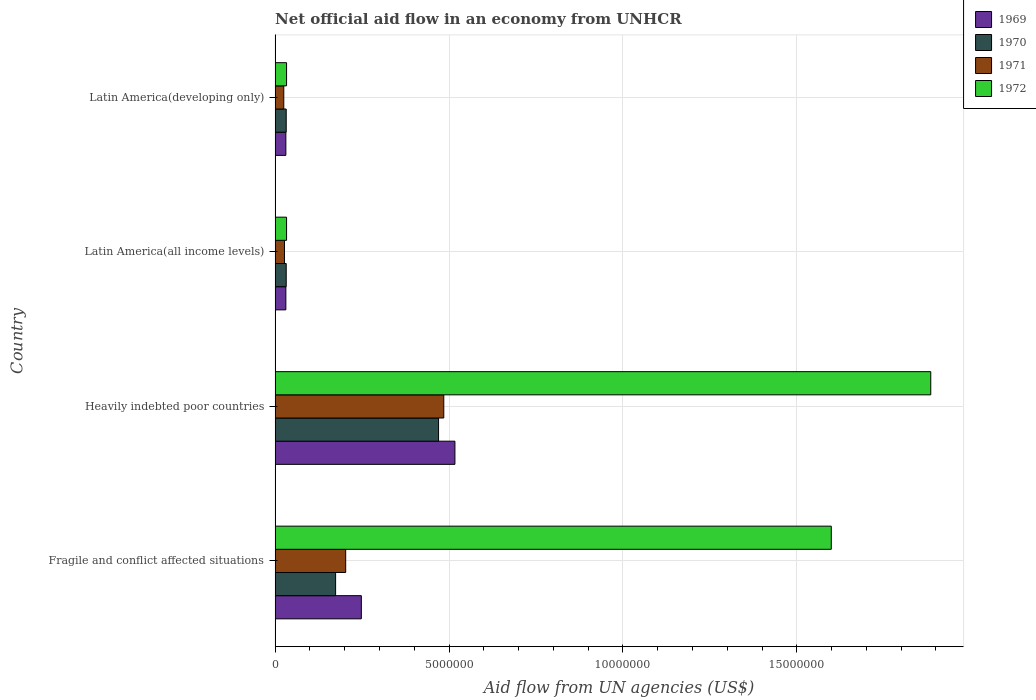How many groups of bars are there?
Offer a very short reply. 4. What is the label of the 4th group of bars from the top?
Offer a terse response. Fragile and conflict affected situations. In how many cases, is the number of bars for a given country not equal to the number of legend labels?
Offer a very short reply. 0. What is the net official aid flow in 1970 in Fragile and conflict affected situations?
Keep it short and to the point. 1.74e+06. Across all countries, what is the maximum net official aid flow in 1971?
Make the answer very short. 4.85e+06. In which country was the net official aid flow in 1970 maximum?
Offer a very short reply. Heavily indebted poor countries. In which country was the net official aid flow in 1972 minimum?
Your answer should be compact. Latin America(all income levels). What is the total net official aid flow in 1969 in the graph?
Keep it short and to the point. 8.27e+06. What is the difference between the net official aid flow in 1971 in Heavily indebted poor countries and that in Latin America(developing only)?
Ensure brevity in your answer.  4.60e+06. What is the difference between the net official aid flow in 1970 in Latin America(all income levels) and the net official aid flow in 1972 in Fragile and conflict affected situations?
Your answer should be compact. -1.57e+07. What is the average net official aid flow in 1972 per country?
Your response must be concise. 8.88e+06. In how many countries, is the net official aid flow in 1972 greater than 12000000 US$?
Offer a very short reply. 2. What is the ratio of the net official aid flow in 1972 in Heavily indebted poor countries to that in Latin America(all income levels)?
Offer a very short reply. 57.12. Is the net official aid flow in 1969 in Heavily indebted poor countries less than that in Latin America(all income levels)?
Your answer should be compact. No. Is the difference between the net official aid flow in 1971 in Heavily indebted poor countries and Latin America(developing only) greater than the difference between the net official aid flow in 1972 in Heavily indebted poor countries and Latin America(developing only)?
Make the answer very short. No. What is the difference between the highest and the second highest net official aid flow in 1969?
Keep it short and to the point. 2.69e+06. What is the difference between the highest and the lowest net official aid flow in 1972?
Offer a very short reply. 1.85e+07. In how many countries, is the net official aid flow in 1969 greater than the average net official aid flow in 1969 taken over all countries?
Offer a terse response. 2. Is the sum of the net official aid flow in 1971 in Fragile and conflict affected situations and Latin America(developing only) greater than the maximum net official aid flow in 1972 across all countries?
Offer a very short reply. No. What does the 4th bar from the top in Latin America(all income levels) represents?
Provide a succinct answer. 1969. What does the 1st bar from the bottom in Fragile and conflict affected situations represents?
Give a very brief answer. 1969. Is it the case that in every country, the sum of the net official aid flow in 1971 and net official aid flow in 1969 is greater than the net official aid flow in 1972?
Provide a short and direct response. No. How many bars are there?
Make the answer very short. 16. Are all the bars in the graph horizontal?
Offer a terse response. Yes. How many countries are there in the graph?
Provide a short and direct response. 4. Does the graph contain grids?
Your answer should be very brief. Yes. How many legend labels are there?
Your response must be concise. 4. How are the legend labels stacked?
Give a very brief answer. Vertical. What is the title of the graph?
Offer a very short reply. Net official aid flow in an economy from UNHCR. Does "1991" appear as one of the legend labels in the graph?
Ensure brevity in your answer.  No. What is the label or title of the X-axis?
Ensure brevity in your answer.  Aid flow from UN agencies (US$). What is the Aid flow from UN agencies (US$) in 1969 in Fragile and conflict affected situations?
Provide a succinct answer. 2.48e+06. What is the Aid flow from UN agencies (US$) in 1970 in Fragile and conflict affected situations?
Provide a succinct answer. 1.74e+06. What is the Aid flow from UN agencies (US$) of 1971 in Fragile and conflict affected situations?
Offer a terse response. 2.03e+06. What is the Aid flow from UN agencies (US$) in 1972 in Fragile and conflict affected situations?
Offer a very short reply. 1.60e+07. What is the Aid flow from UN agencies (US$) of 1969 in Heavily indebted poor countries?
Make the answer very short. 5.17e+06. What is the Aid flow from UN agencies (US$) in 1970 in Heavily indebted poor countries?
Give a very brief answer. 4.70e+06. What is the Aid flow from UN agencies (US$) in 1971 in Heavily indebted poor countries?
Make the answer very short. 4.85e+06. What is the Aid flow from UN agencies (US$) of 1972 in Heavily indebted poor countries?
Provide a succinct answer. 1.88e+07. What is the Aid flow from UN agencies (US$) in 1969 in Latin America(all income levels)?
Make the answer very short. 3.10e+05. What is the Aid flow from UN agencies (US$) of 1970 in Latin America(all income levels)?
Offer a very short reply. 3.20e+05. What is the Aid flow from UN agencies (US$) in 1971 in Latin America(all income levels)?
Provide a succinct answer. 2.70e+05. What is the Aid flow from UN agencies (US$) in 1972 in Latin America(all income levels)?
Keep it short and to the point. 3.30e+05. What is the Aid flow from UN agencies (US$) of 1971 in Latin America(developing only)?
Your answer should be very brief. 2.50e+05. Across all countries, what is the maximum Aid flow from UN agencies (US$) in 1969?
Your response must be concise. 5.17e+06. Across all countries, what is the maximum Aid flow from UN agencies (US$) of 1970?
Give a very brief answer. 4.70e+06. Across all countries, what is the maximum Aid flow from UN agencies (US$) of 1971?
Provide a short and direct response. 4.85e+06. Across all countries, what is the maximum Aid flow from UN agencies (US$) in 1972?
Give a very brief answer. 1.88e+07. Across all countries, what is the minimum Aid flow from UN agencies (US$) of 1969?
Offer a terse response. 3.10e+05. Across all countries, what is the minimum Aid flow from UN agencies (US$) of 1972?
Provide a short and direct response. 3.30e+05. What is the total Aid flow from UN agencies (US$) of 1969 in the graph?
Your response must be concise. 8.27e+06. What is the total Aid flow from UN agencies (US$) in 1970 in the graph?
Provide a short and direct response. 7.08e+06. What is the total Aid flow from UN agencies (US$) of 1971 in the graph?
Ensure brevity in your answer.  7.40e+06. What is the total Aid flow from UN agencies (US$) of 1972 in the graph?
Offer a terse response. 3.55e+07. What is the difference between the Aid flow from UN agencies (US$) in 1969 in Fragile and conflict affected situations and that in Heavily indebted poor countries?
Make the answer very short. -2.69e+06. What is the difference between the Aid flow from UN agencies (US$) of 1970 in Fragile and conflict affected situations and that in Heavily indebted poor countries?
Give a very brief answer. -2.96e+06. What is the difference between the Aid flow from UN agencies (US$) in 1971 in Fragile and conflict affected situations and that in Heavily indebted poor countries?
Give a very brief answer. -2.82e+06. What is the difference between the Aid flow from UN agencies (US$) of 1972 in Fragile and conflict affected situations and that in Heavily indebted poor countries?
Your answer should be compact. -2.86e+06. What is the difference between the Aid flow from UN agencies (US$) of 1969 in Fragile and conflict affected situations and that in Latin America(all income levels)?
Ensure brevity in your answer.  2.17e+06. What is the difference between the Aid flow from UN agencies (US$) of 1970 in Fragile and conflict affected situations and that in Latin America(all income levels)?
Offer a terse response. 1.42e+06. What is the difference between the Aid flow from UN agencies (US$) in 1971 in Fragile and conflict affected situations and that in Latin America(all income levels)?
Make the answer very short. 1.76e+06. What is the difference between the Aid flow from UN agencies (US$) of 1972 in Fragile and conflict affected situations and that in Latin America(all income levels)?
Provide a succinct answer. 1.57e+07. What is the difference between the Aid flow from UN agencies (US$) in 1969 in Fragile and conflict affected situations and that in Latin America(developing only)?
Provide a short and direct response. 2.17e+06. What is the difference between the Aid flow from UN agencies (US$) of 1970 in Fragile and conflict affected situations and that in Latin America(developing only)?
Offer a terse response. 1.42e+06. What is the difference between the Aid flow from UN agencies (US$) of 1971 in Fragile and conflict affected situations and that in Latin America(developing only)?
Offer a terse response. 1.78e+06. What is the difference between the Aid flow from UN agencies (US$) of 1972 in Fragile and conflict affected situations and that in Latin America(developing only)?
Provide a succinct answer. 1.57e+07. What is the difference between the Aid flow from UN agencies (US$) in 1969 in Heavily indebted poor countries and that in Latin America(all income levels)?
Offer a terse response. 4.86e+06. What is the difference between the Aid flow from UN agencies (US$) in 1970 in Heavily indebted poor countries and that in Latin America(all income levels)?
Make the answer very short. 4.38e+06. What is the difference between the Aid flow from UN agencies (US$) of 1971 in Heavily indebted poor countries and that in Latin America(all income levels)?
Your response must be concise. 4.58e+06. What is the difference between the Aid flow from UN agencies (US$) in 1972 in Heavily indebted poor countries and that in Latin America(all income levels)?
Provide a short and direct response. 1.85e+07. What is the difference between the Aid flow from UN agencies (US$) in 1969 in Heavily indebted poor countries and that in Latin America(developing only)?
Offer a very short reply. 4.86e+06. What is the difference between the Aid flow from UN agencies (US$) of 1970 in Heavily indebted poor countries and that in Latin America(developing only)?
Offer a terse response. 4.38e+06. What is the difference between the Aid flow from UN agencies (US$) of 1971 in Heavily indebted poor countries and that in Latin America(developing only)?
Provide a succinct answer. 4.60e+06. What is the difference between the Aid flow from UN agencies (US$) of 1972 in Heavily indebted poor countries and that in Latin America(developing only)?
Offer a terse response. 1.85e+07. What is the difference between the Aid flow from UN agencies (US$) in 1969 in Latin America(all income levels) and that in Latin America(developing only)?
Offer a terse response. 0. What is the difference between the Aid flow from UN agencies (US$) of 1970 in Latin America(all income levels) and that in Latin America(developing only)?
Make the answer very short. 0. What is the difference between the Aid flow from UN agencies (US$) in 1971 in Latin America(all income levels) and that in Latin America(developing only)?
Offer a very short reply. 2.00e+04. What is the difference between the Aid flow from UN agencies (US$) in 1969 in Fragile and conflict affected situations and the Aid flow from UN agencies (US$) in 1970 in Heavily indebted poor countries?
Your response must be concise. -2.22e+06. What is the difference between the Aid flow from UN agencies (US$) of 1969 in Fragile and conflict affected situations and the Aid flow from UN agencies (US$) of 1971 in Heavily indebted poor countries?
Your answer should be very brief. -2.37e+06. What is the difference between the Aid flow from UN agencies (US$) of 1969 in Fragile and conflict affected situations and the Aid flow from UN agencies (US$) of 1972 in Heavily indebted poor countries?
Your response must be concise. -1.64e+07. What is the difference between the Aid flow from UN agencies (US$) of 1970 in Fragile and conflict affected situations and the Aid flow from UN agencies (US$) of 1971 in Heavily indebted poor countries?
Your answer should be very brief. -3.11e+06. What is the difference between the Aid flow from UN agencies (US$) of 1970 in Fragile and conflict affected situations and the Aid flow from UN agencies (US$) of 1972 in Heavily indebted poor countries?
Your answer should be compact. -1.71e+07. What is the difference between the Aid flow from UN agencies (US$) of 1971 in Fragile and conflict affected situations and the Aid flow from UN agencies (US$) of 1972 in Heavily indebted poor countries?
Offer a terse response. -1.68e+07. What is the difference between the Aid flow from UN agencies (US$) of 1969 in Fragile and conflict affected situations and the Aid flow from UN agencies (US$) of 1970 in Latin America(all income levels)?
Provide a succinct answer. 2.16e+06. What is the difference between the Aid flow from UN agencies (US$) in 1969 in Fragile and conflict affected situations and the Aid flow from UN agencies (US$) in 1971 in Latin America(all income levels)?
Your response must be concise. 2.21e+06. What is the difference between the Aid flow from UN agencies (US$) in 1969 in Fragile and conflict affected situations and the Aid flow from UN agencies (US$) in 1972 in Latin America(all income levels)?
Your response must be concise. 2.15e+06. What is the difference between the Aid flow from UN agencies (US$) of 1970 in Fragile and conflict affected situations and the Aid flow from UN agencies (US$) of 1971 in Latin America(all income levels)?
Make the answer very short. 1.47e+06. What is the difference between the Aid flow from UN agencies (US$) in 1970 in Fragile and conflict affected situations and the Aid flow from UN agencies (US$) in 1972 in Latin America(all income levels)?
Ensure brevity in your answer.  1.41e+06. What is the difference between the Aid flow from UN agencies (US$) of 1971 in Fragile and conflict affected situations and the Aid flow from UN agencies (US$) of 1972 in Latin America(all income levels)?
Make the answer very short. 1.70e+06. What is the difference between the Aid flow from UN agencies (US$) in 1969 in Fragile and conflict affected situations and the Aid flow from UN agencies (US$) in 1970 in Latin America(developing only)?
Make the answer very short. 2.16e+06. What is the difference between the Aid flow from UN agencies (US$) of 1969 in Fragile and conflict affected situations and the Aid flow from UN agencies (US$) of 1971 in Latin America(developing only)?
Ensure brevity in your answer.  2.23e+06. What is the difference between the Aid flow from UN agencies (US$) of 1969 in Fragile and conflict affected situations and the Aid flow from UN agencies (US$) of 1972 in Latin America(developing only)?
Your response must be concise. 2.15e+06. What is the difference between the Aid flow from UN agencies (US$) in 1970 in Fragile and conflict affected situations and the Aid flow from UN agencies (US$) in 1971 in Latin America(developing only)?
Make the answer very short. 1.49e+06. What is the difference between the Aid flow from UN agencies (US$) in 1970 in Fragile and conflict affected situations and the Aid flow from UN agencies (US$) in 1972 in Latin America(developing only)?
Keep it short and to the point. 1.41e+06. What is the difference between the Aid flow from UN agencies (US$) in 1971 in Fragile and conflict affected situations and the Aid flow from UN agencies (US$) in 1972 in Latin America(developing only)?
Your answer should be compact. 1.70e+06. What is the difference between the Aid flow from UN agencies (US$) of 1969 in Heavily indebted poor countries and the Aid flow from UN agencies (US$) of 1970 in Latin America(all income levels)?
Make the answer very short. 4.85e+06. What is the difference between the Aid flow from UN agencies (US$) in 1969 in Heavily indebted poor countries and the Aid flow from UN agencies (US$) in 1971 in Latin America(all income levels)?
Your response must be concise. 4.90e+06. What is the difference between the Aid flow from UN agencies (US$) of 1969 in Heavily indebted poor countries and the Aid flow from UN agencies (US$) of 1972 in Latin America(all income levels)?
Your answer should be very brief. 4.84e+06. What is the difference between the Aid flow from UN agencies (US$) in 1970 in Heavily indebted poor countries and the Aid flow from UN agencies (US$) in 1971 in Latin America(all income levels)?
Your answer should be very brief. 4.43e+06. What is the difference between the Aid flow from UN agencies (US$) of 1970 in Heavily indebted poor countries and the Aid flow from UN agencies (US$) of 1972 in Latin America(all income levels)?
Give a very brief answer. 4.37e+06. What is the difference between the Aid flow from UN agencies (US$) of 1971 in Heavily indebted poor countries and the Aid flow from UN agencies (US$) of 1972 in Latin America(all income levels)?
Give a very brief answer. 4.52e+06. What is the difference between the Aid flow from UN agencies (US$) of 1969 in Heavily indebted poor countries and the Aid flow from UN agencies (US$) of 1970 in Latin America(developing only)?
Provide a short and direct response. 4.85e+06. What is the difference between the Aid flow from UN agencies (US$) in 1969 in Heavily indebted poor countries and the Aid flow from UN agencies (US$) in 1971 in Latin America(developing only)?
Offer a very short reply. 4.92e+06. What is the difference between the Aid flow from UN agencies (US$) in 1969 in Heavily indebted poor countries and the Aid flow from UN agencies (US$) in 1972 in Latin America(developing only)?
Give a very brief answer. 4.84e+06. What is the difference between the Aid flow from UN agencies (US$) in 1970 in Heavily indebted poor countries and the Aid flow from UN agencies (US$) in 1971 in Latin America(developing only)?
Ensure brevity in your answer.  4.45e+06. What is the difference between the Aid flow from UN agencies (US$) of 1970 in Heavily indebted poor countries and the Aid flow from UN agencies (US$) of 1972 in Latin America(developing only)?
Offer a terse response. 4.37e+06. What is the difference between the Aid flow from UN agencies (US$) in 1971 in Heavily indebted poor countries and the Aid flow from UN agencies (US$) in 1972 in Latin America(developing only)?
Your answer should be compact. 4.52e+06. What is the difference between the Aid flow from UN agencies (US$) in 1969 in Latin America(all income levels) and the Aid flow from UN agencies (US$) in 1972 in Latin America(developing only)?
Offer a very short reply. -2.00e+04. What is the average Aid flow from UN agencies (US$) in 1969 per country?
Offer a terse response. 2.07e+06. What is the average Aid flow from UN agencies (US$) in 1970 per country?
Ensure brevity in your answer.  1.77e+06. What is the average Aid flow from UN agencies (US$) of 1971 per country?
Your response must be concise. 1.85e+06. What is the average Aid flow from UN agencies (US$) in 1972 per country?
Provide a succinct answer. 8.88e+06. What is the difference between the Aid flow from UN agencies (US$) in 1969 and Aid flow from UN agencies (US$) in 1970 in Fragile and conflict affected situations?
Make the answer very short. 7.40e+05. What is the difference between the Aid flow from UN agencies (US$) in 1969 and Aid flow from UN agencies (US$) in 1972 in Fragile and conflict affected situations?
Make the answer very short. -1.35e+07. What is the difference between the Aid flow from UN agencies (US$) in 1970 and Aid flow from UN agencies (US$) in 1972 in Fragile and conflict affected situations?
Your answer should be very brief. -1.42e+07. What is the difference between the Aid flow from UN agencies (US$) of 1971 and Aid flow from UN agencies (US$) of 1972 in Fragile and conflict affected situations?
Provide a short and direct response. -1.40e+07. What is the difference between the Aid flow from UN agencies (US$) in 1969 and Aid flow from UN agencies (US$) in 1971 in Heavily indebted poor countries?
Provide a succinct answer. 3.20e+05. What is the difference between the Aid flow from UN agencies (US$) in 1969 and Aid flow from UN agencies (US$) in 1972 in Heavily indebted poor countries?
Provide a succinct answer. -1.37e+07. What is the difference between the Aid flow from UN agencies (US$) in 1970 and Aid flow from UN agencies (US$) in 1971 in Heavily indebted poor countries?
Your answer should be compact. -1.50e+05. What is the difference between the Aid flow from UN agencies (US$) in 1970 and Aid flow from UN agencies (US$) in 1972 in Heavily indebted poor countries?
Keep it short and to the point. -1.42e+07. What is the difference between the Aid flow from UN agencies (US$) of 1971 and Aid flow from UN agencies (US$) of 1972 in Heavily indebted poor countries?
Provide a short and direct response. -1.40e+07. What is the difference between the Aid flow from UN agencies (US$) in 1970 and Aid flow from UN agencies (US$) in 1971 in Latin America(all income levels)?
Your answer should be compact. 5.00e+04. What is the difference between the Aid flow from UN agencies (US$) of 1971 and Aid flow from UN agencies (US$) of 1972 in Latin America(all income levels)?
Your answer should be compact. -6.00e+04. What is the difference between the Aid flow from UN agencies (US$) in 1969 and Aid flow from UN agencies (US$) in 1971 in Latin America(developing only)?
Offer a terse response. 6.00e+04. What is the difference between the Aid flow from UN agencies (US$) of 1969 and Aid flow from UN agencies (US$) of 1972 in Latin America(developing only)?
Offer a terse response. -2.00e+04. What is the difference between the Aid flow from UN agencies (US$) of 1970 and Aid flow from UN agencies (US$) of 1971 in Latin America(developing only)?
Give a very brief answer. 7.00e+04. What is the difference between the Aid flow from UN agencies (US$) in 1970 and Aid flow from UN agencies (US$) in 1972 in Latin America(developing only)?
Offer a terse response. -10000. What is the ratio of the Aid flow from UN agencies (US$) of 1969 in Fragile and conflict affected situations to that in Heavily indebted poor countries?
Make the answer very short. 0.48. What is the ratio of the Aid flow from UN agencies (US$) in 1970 in Fragile and conflict affected situations to that in Heavily indebted poor countries?
Provide a succinct answer. 0.37. What is the ratio of the Aid flow from UN agencies (US$) in 1971 in Fragile and conflict affected situations to that in Heavily indebted poor countries?
Offer a terse response. 0.42. What is the ratio of the Aid flow from UN agencies (US$) of 1972 in Fragile and conflict affected situations to that in Heavily indebted poor countries?
Offer a terse response. 0.85. What is the ratio of the Aid flow from UN agencies (US$) in 1970 in Fragile and conflict affected situations to that in Latin America(all income levels)?
Your answer should be compact. 5.44. What is the ratio of the Aid flow from UN agencies (US$) of 1971 in Fragile and conflict affected situations to that in Latin America(all income levels)?
Provide a succinct answer. 7.52. What is the ratio of the Aid flow from UN agencies (US$) in 1972 in Fragile and conflict affected situations to that in Latin America(all income levels)?
Provide a succinct answer. 48.45. What is the ratio of the Aid flow from UN agencies (US$) in 1969 in Fragile and conflict affected situations to that in Latin America(developing only)?
Your answer should be very brief. 8. What is the ratio of the Aid flow from UN agencies (US$) in 1970 in Fragile and conflict affected situations to that in Latin America(developing only)?
Keep it short and to the point. 5.44. What is the ratio of the Aid flow from UN agencies (US$) in 1971 in Fragile and conflict affected situations to that in Latin America(developing only)?
Keep it short and to the point. 8.12. What is the ratio of the Aid flow from UN agencies (US$) in 1972 in Fragile and conflict affected situations to that in Latin America(developing only)?
Offer a very short reply. 48.45. What is the ratio of the Aid flow from UN agencies (US$) in 1969 in Heavily indebted poor countries to that in Latin America(all income levels)?
Your response must be concise. 16.68. What is the ratio of the Aid flow from UN agencies (US$) in 1970 in Heavily indebted poor countries to that in Latin America(all income levels)?
Give a very brief answer. 14.69. What is the ratio of the Aid flow from UN agencies (US$) of 1971 in Heavily indebted poor countries to that in Latin America(all income levels)?
Give a very brief answer. 17.96. What is the ratio of the Aid flow from UN agencies (US$) of 1972 in Heavily indebted poor countries to that in Latin America(all income levels)?
Your answer should be very brief. 57.12. What is the ratio of the Aid flow from UN agencies (US$) in 1969 in Heavily indebted poor countries to that in Latin America(developing only)?
Offer a terse response. 16.68. What is the ratio of the Aid flow from UN agencies (US$) in 1970 in Heavily indebted poor countries to that in Latin America(developing only)?
Keep it short and to the point. 14.69. What is the ratio of the Aid flow from UN agencies (US$) of 1972 in Heavily indebted poor countries to that in Latin America(developing only)?
Your response must be concise. 57.12. What is the ratio of the Aid flow from UN agencies (US$) in 1971 in Latin America(all income levels) to that in Latin America(developing only)?
Provide a short and direct response. 1.08. What is the ratio of the Aid flow from UN agencies (US$) in 1972 in Latin America(all income levels) to that in Latin America(developing only)?
Provide a short and direct response. 1. What is the difference between the highest and the second highest Aid flow from UN agencies (US$) of 1969?
Give a very brief answer. 2.69e+06. What is the difference between the highest and the second highest Aid flow from UN agencies (US$) in 1970?
Make the answer very short. 2.96e+06. What is the difference between the highest and the second highest Aid flow from UN agencies (US$) in 1971?
Keep it short and to the point. 2.82e+06. What is the difference between the highest and the second highest Aid flow from UN agencies (US$) of 1972?
Offer a very short reply. 2.86e+06. What is the difference between the highest and the lowest Aid flow from UN agencies (US$) in 1969?
Keep it short and to the point. 4.86e+06. What is the difference between the highest and the lowest Aid flow from UN agencies (US$) in 1970?
Your answer should be compact. 4.38e+06. What is the difference between the highest and the lowest Aid flow from UN agencies (US$) in 1971?
Provide a succinct answer. 4.60e+06. What is the difference between the highest and the lowest Aid flow from UN agencies (US$) in 1972?
Offer a terse response. 1.85e+07. 